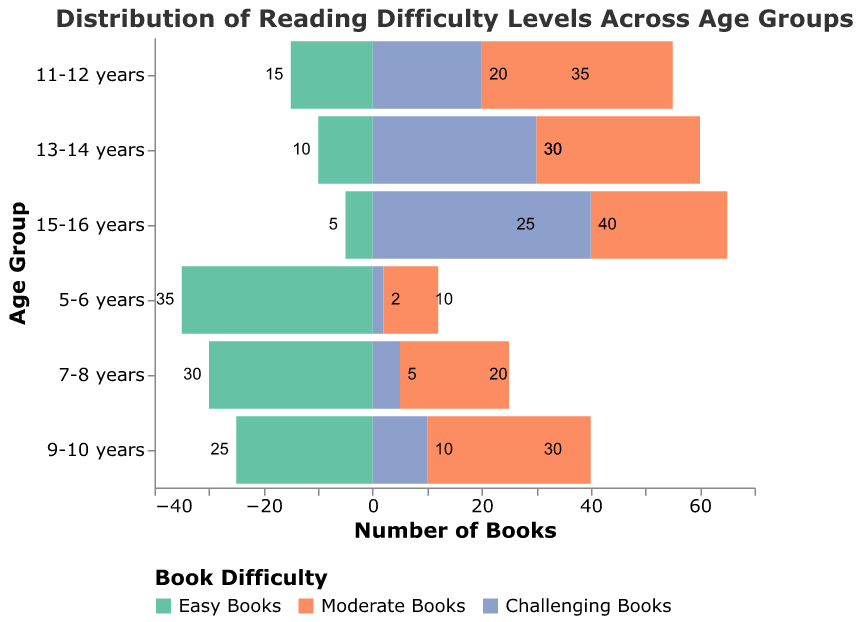What is the title of the figure? The title of a figure is usually placed at the top, and we can see it clearly declares the subject matter.
Answer: Distribution of Reading Difficulty Levels Across Age Groups Which age group has the highest number of easy books? By looking at the bars representing easy books (colored in light green), we see that the 5-6 years age group has the longest bar, indicating the highest number of easy books.
Answer: 5-6 years Which category of books do 15-16 years old students read the most? The bars for each book difficulty level can be checked for the 15-16 years age group. The longest bar represents challenging books (colored in blue).
Answer: Challenging Books In the 11-12 years age group, what is the difference in the number of moderate books and easy books? You look at the bars for the 11-12 years age group: Moderate Books is 35, Easy Books is 15. The difference is calculated as 35 - 15.
Answer: 20 How many more challenging books than easy books are there for the 13-14 years age group? Examine the bars for the 13-14 years age group: Challenging Books is 30, Easy Books is 10. Subtract to find the difference: 30 - 10.
Answer: 20 Which age group has the most balanced distribution of books across all difficulty levels? A balanced distribution means the bars' lengths are more or less equal. For the 13-14 years age group, the books are distributed as 10, 30, and 30, which looks most balanced comparatively.
Answer: 13-14 years What is the total number of books for the 7-8 years age group? Sum the values for easy, moderate, and challenging books for 7-8 years: 30 (Easy) + 20 (Moderate) + 5 (Challenging) = 55.
Answer: 55 Which age group spends the most time reading moderate books compared to other types? By comparing the lengths of the moderate books bars across all age groups, the 11-12 years group stands out with the longest bar of 35.
Answer: 11-12 years What trend do you observe about the distribution of challenging books as age increases? Observing the bars for challenging books across increasing age groups, we see that the number of challenging books consistently increases from 5 years to 16 years.
Answer: Increases with age 